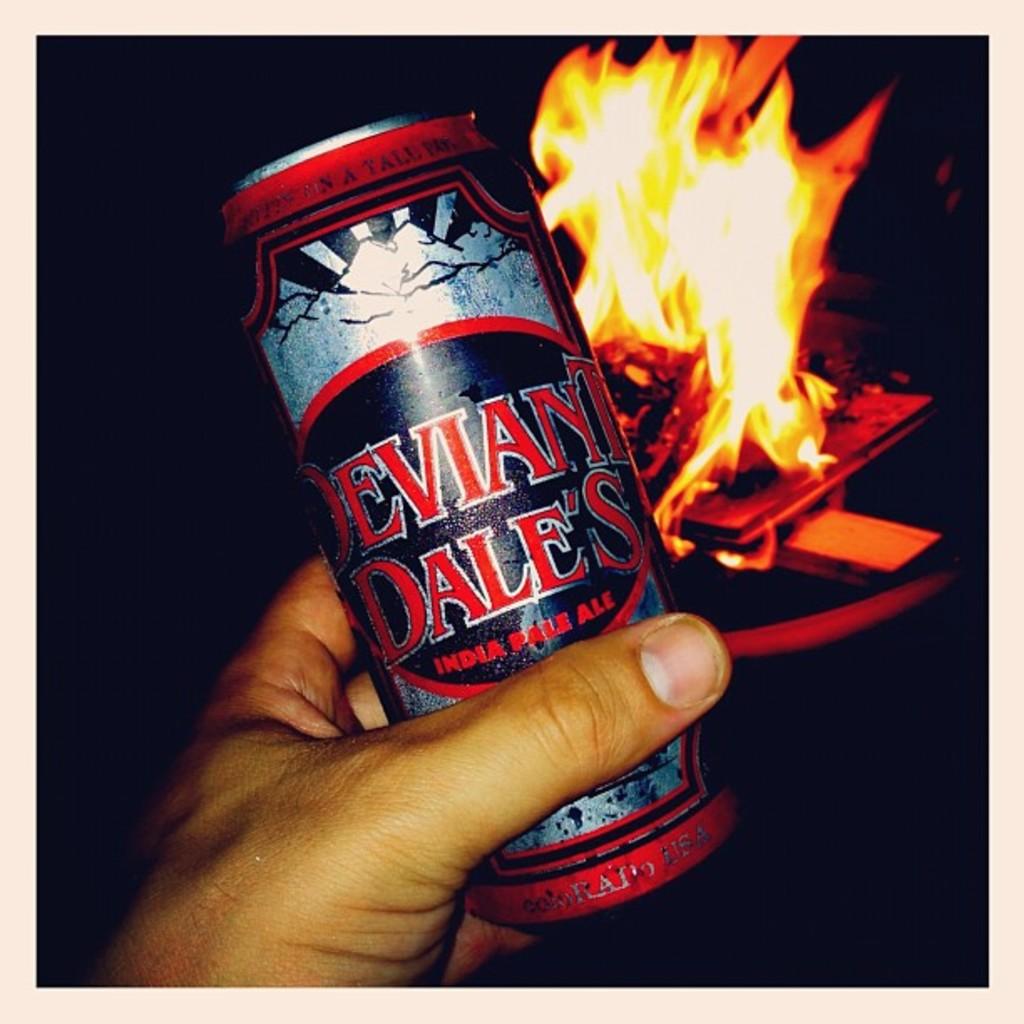What brand is mentioned on the can?
Offer a very short reply. Deviant dale's. 